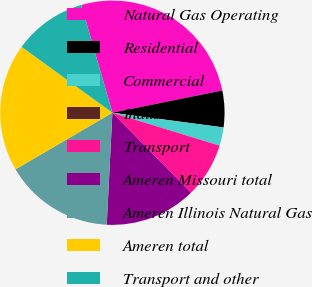<chart> <loc_0><loc_0><loc_500><loc_500><pie_chart><fcel>Natural Gas Operating<fcel>Residential<fcel>Commercial<fcel>Industrial<fcel>Transport<fcel>Ameren Missouri total<fcel>Ameren Illinois Natural Gas<fcel>Ameren total<fcel>Transport and other<nl><fcel>26.3%<fcel>5.27%<fcel>2.64%<fcel>0.01%<fcel>7.9%<fcel>13.16%<fcel>15.78%<fcel>18.41%<fcel>10.53%<nl></chart> 